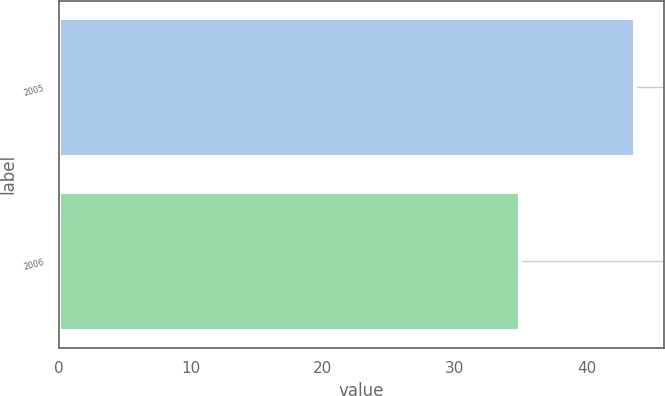Convert chart to OTSL. <chart><loc_0><loc_0><loc_500><loc_500><bar_chart><fcel>2005<fcel>2006<nl><fcel>43.71<fcel>34.93<nl></chart> 